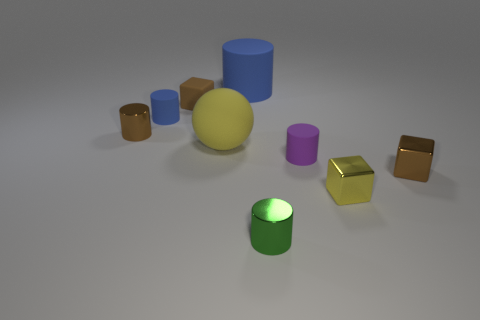Subtract all brown cylinders. How many cylinders are left? 4 Subtract 2 cylinders. How many cylinders are left? 3 Subtract all tiny purple cylinders. How many cylinders are left? 4 Subtract all gray cylinders. Subtract all red balls. How many cylinders are left? 5 Add 1 small yellow things. How many objects exist? 10 Subtract all balls. How many objects are left? 8 Subtract 0 blue cubes. How many objects are left? 9 Subtract all metal blocks. Subtract all green things. How many objects are left? 6 Add 3 tiny yellow metal objects. How many tiny yellow metal objects are left? 4 Add 1 tiny purple matte cylinders. How many tiny purple matte cylinders exist? 2 